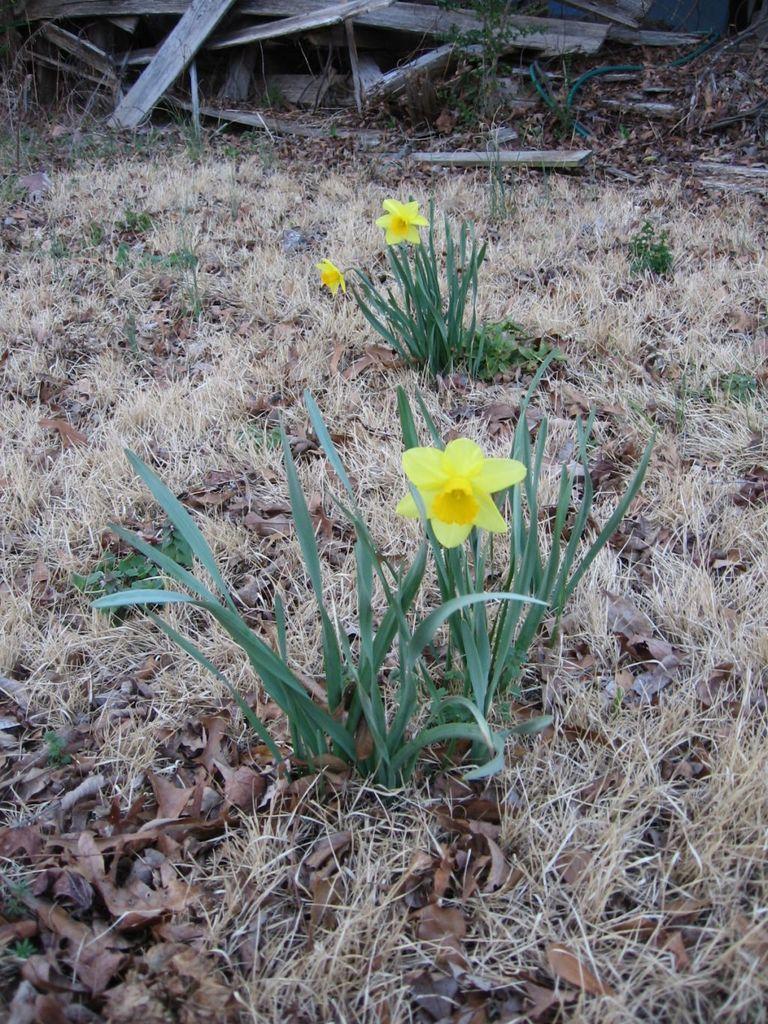Describe this image in one or two sentences. In this image we can see the plants and flowers and there are some dry leaves and grass on the ground. We can see some wooden objects in the background. 